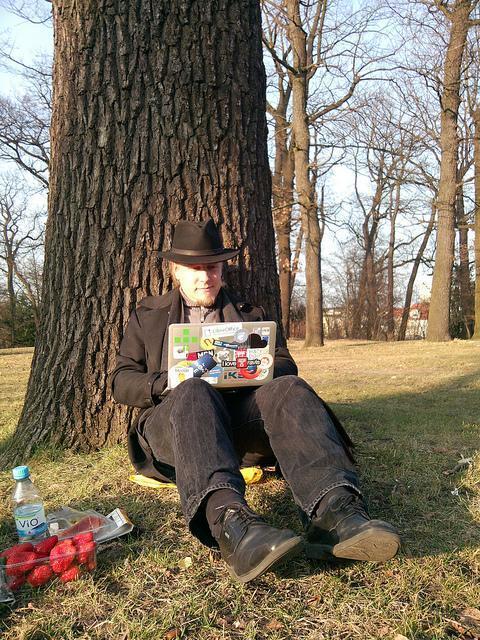How many people are there?
Give a very brief answer. 1. 